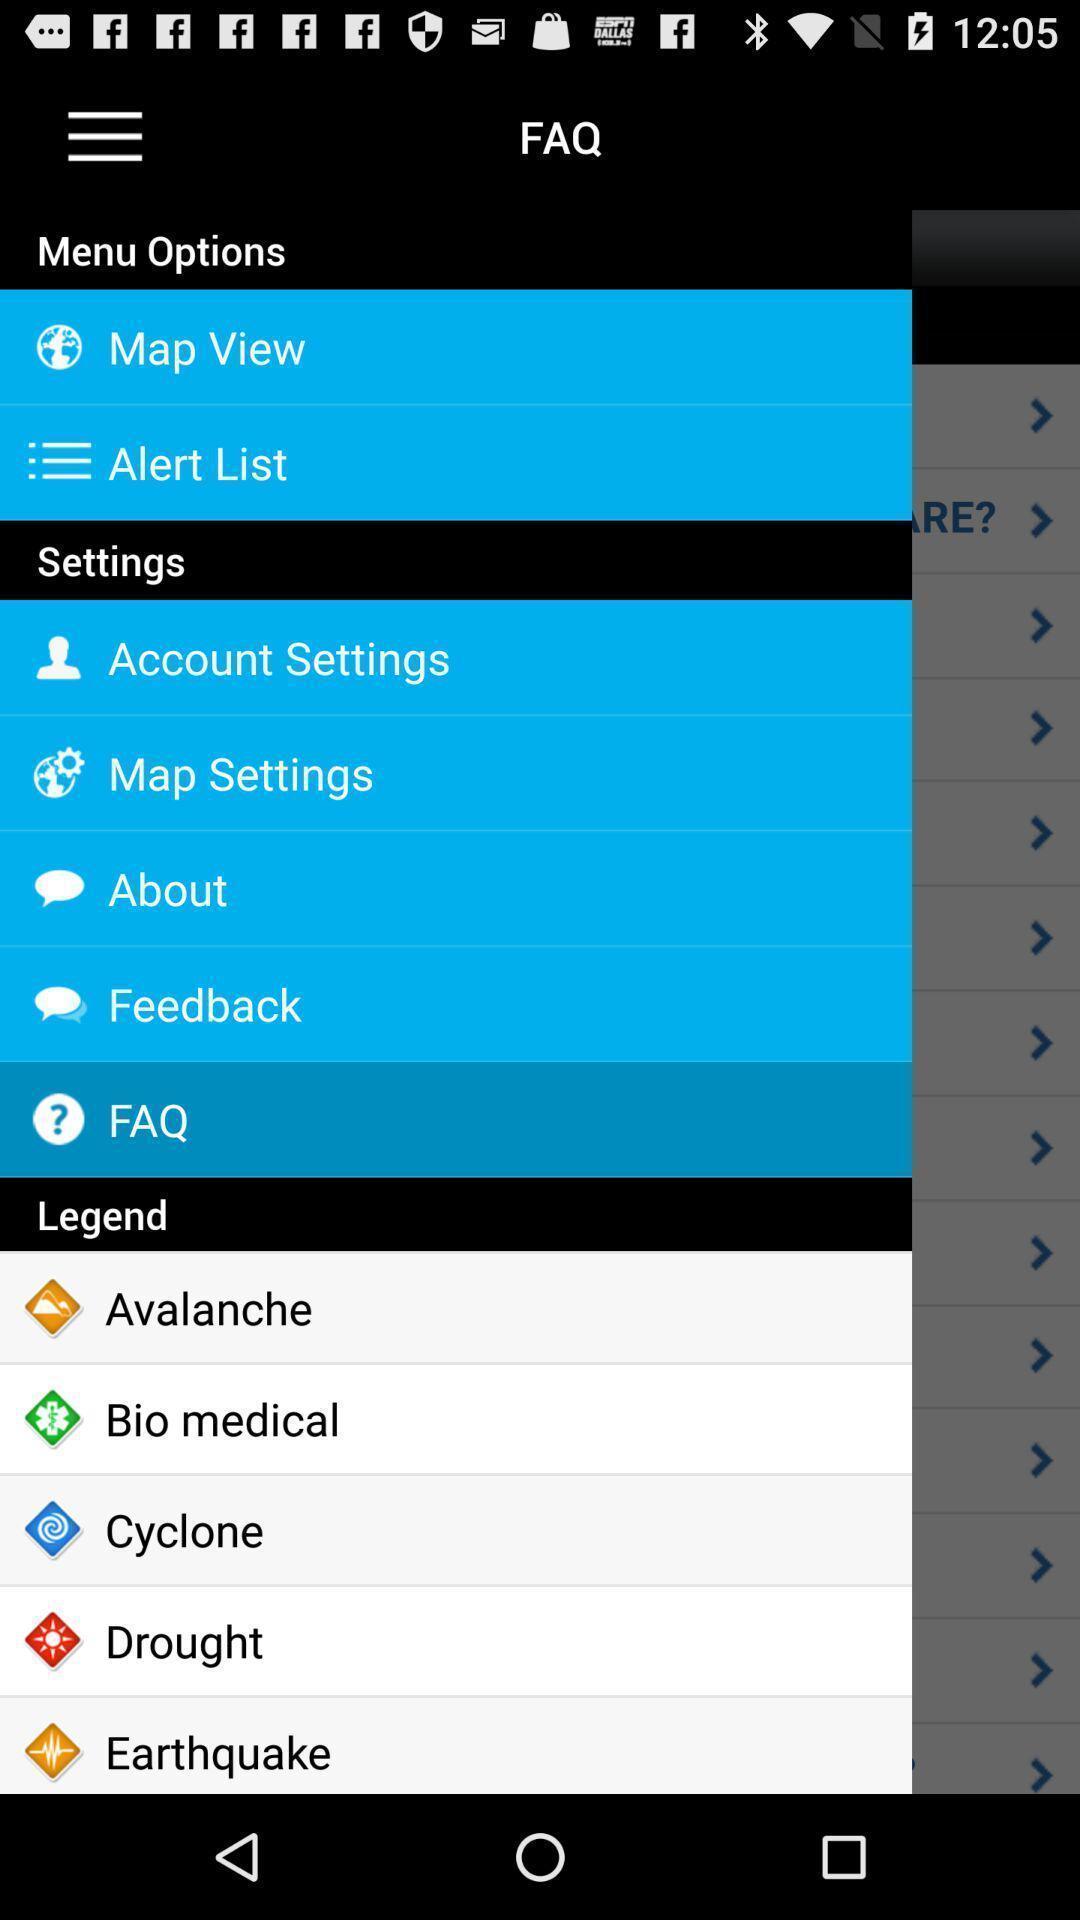Describe the visual elements of this screenshot. Screen displaying list of options. 